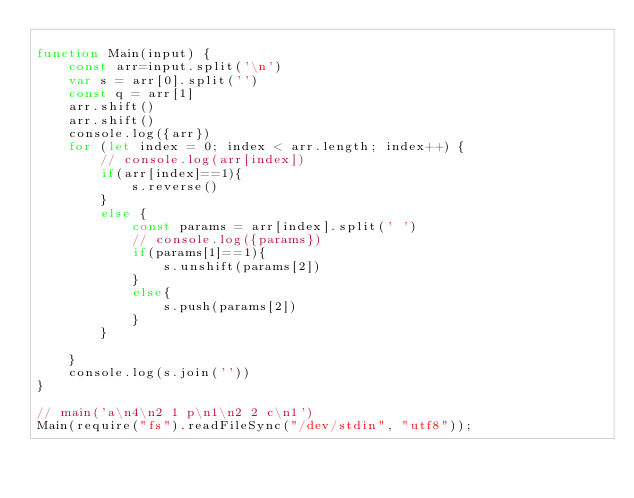Convert code to text. <code><loc_0><loc_0><loc_500><loc_500><_JavaScript_>
function Main(input) {
    const arr=input.split('\n')
    var s = arr[0].split('')
    const q = arr[1]
    arr.shift()
    arr.shift()
    console.log({arr})
    for (let index = 0; index < arr.length; index++) {
        // console.log(arr[index])
        if(arr[index]==1){
            s.reverse()   
        }
        else {
            const params = arr[index].split(' ')
            // console.log({params})
            if(params[1]==1){
                s.unshift(params[2])
            }
            else{
                s.push(params[2])
            }
        }
        
    }
    console.log(s.join(''))
}

// main('a\n4\n2 1 p\n1\n2 2 c\n1')
Main(require("fs").readFileSync("/dev/stdin", "utf8"));
</code> 